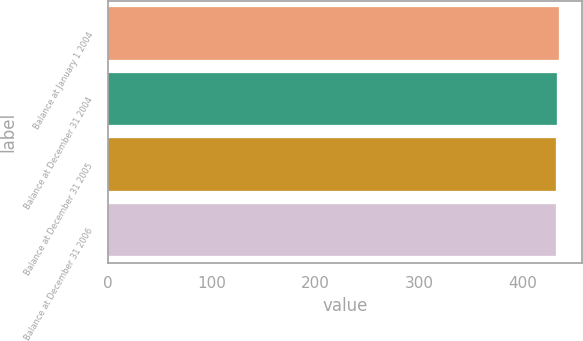Convert chart. <chart><loc_0><loc_0><loc_500><loc_500><bar_chart><fcel>Balance at January 1 2004<fcel>Balance at December 31 2004<fcel>Balance at December 31 2005<fcel>Balance at December 31 2006<nl><fcel>435<fcel>433<fcel>432<fcel>432.3<nl></chart> 